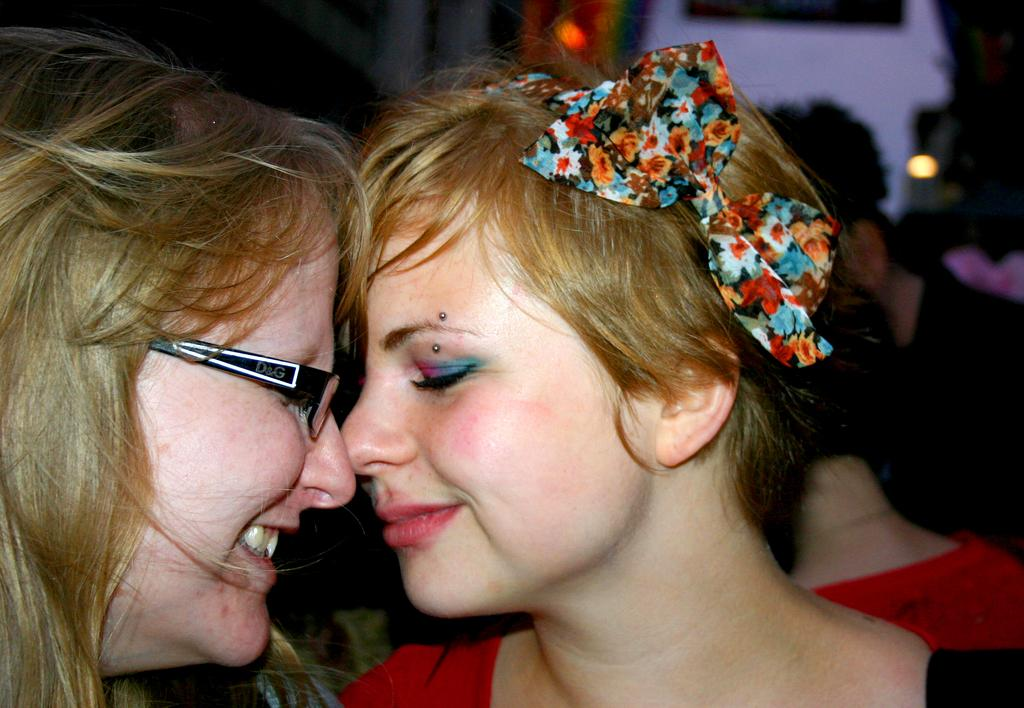How many people are in the image? There are four people in the image. What are the people in the image doing? The two persons are smiling in the image. Can you describe the background of the image? The background of the image is blurred. What type of dog can be seen playing with the fairies in the image? There is no dog or fairies present in the image; it features four people, two of whom are smiling. What kind of cloud formation is visible in the image? There is no cloud formation visible in the image, as the background is blurred. 